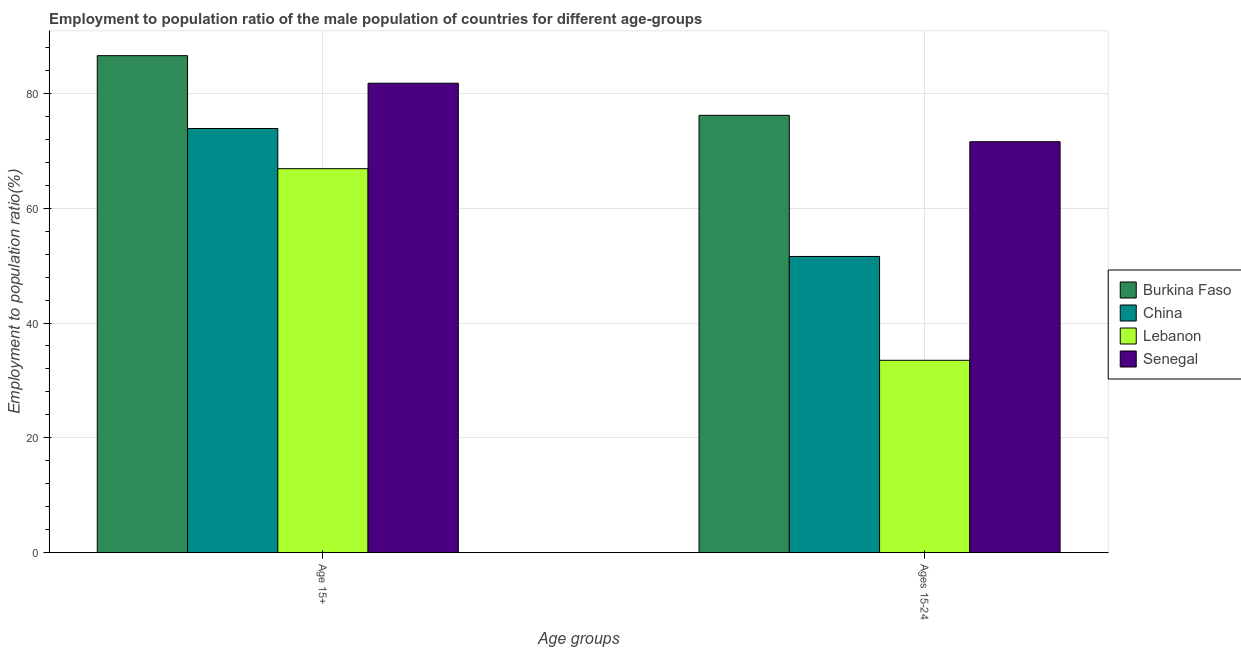How many different coloured bars are there?
Make the answer very short. 4. How many bars are there on the 2nd tick from the right?
Offer a terse response. 4. What is the label of the 1st group of bars from the left?
Your answer should be very brief. Age 15+. What is the employment to population ratio(age 15+) in Senegal?
Provide a short and direct response. 81.8. Across all countries, what is the maximum employment to population ratio(age 15-24)?
Keep it short and to the point. 76.2. Across all countries, what is the minimum employment to population ratio(age 15-24)?
Your answer should be very brief. 33.5. In which country was the employment to population ratio(age 15-24) maximum?
Give a very brief answer. Burkina Faso. In which country was the employment to population ratio(age 15+) minimum?
Provide a short and direct response. Lebanon. What is the total employment to population ratio(age 15-24) in the graph?
Your response must be concise. 232.9. What is the difference between the employment to population ratio(age 15+) in Burkina Faso and that in Senegal?
Offer a very short reply. 4.8. What is the difference between the employment to population ratio(age 15-24) in China and the employment to population ratio(age 15+) in Senegal?
Give a very brief answer. -30.2. What is the average employment to population ratio(age 15-24) per country?
Your response must be concise. 58.22. What is the difference between the employment to population ratio(age 15-24) and employment to population ratio(age 15+) in China?
Your response must be concise. -22.3. What is the ratio of the employment to population ratio(age 15+) in Lebanon to that in China?
Keep it short and to the point. 0.91. What does the 2nd bar from the left in Ages 15-24 represents?
Give a very brief answer. China. What does the 2nd bar from the right in Ages 15-24 represents?
Give a very brief answer. Lebanon. How many bars are there?
Offer a terse response. 8. What is the difference between two consecutive major ticks on the Y-axis?
Give a very brief answer. 20. Are the values on the major ticks of Y-axis written in scientific E-notation?
Your answer should be very brief. No. Does the graph contain grids?
Provide a succinct answer. Yes. Where does the legend appear in the graph?
Your answer should be very brief. Center right. How are the legend labels stacked?
Your answer should be compact. Vertical. What is the title of the graph?
Offer a terse response. Employment to population ratio of the male population of countries for different age-groups. Does "Costa Rica" appear as one of the legend labels in the graph?
Your answer should be very brief. No. What is the label or title of the X-axis?
Give a very brief answer. Age groups. What is the Employment to population ratio(%) in Burkina Faso in Age 15+?
Give a very brief answer. 86.6. What is the Employment to population ratio(%) in China in Age 15+?
Make the answer very short. 73.9. What is the Employment to population ratio(%) in Lebanon in Age 15+?
Make the answer very short. 66.9. What is the Employment to population ratio(%) of Senegal in Age 15+?
Keep it short and to the point. 81.8. What is the Employment to population ratio(%) in Burkina Faso in Ages 15-24?
Ensure brevity in your answer.  76.2. What is the Employment to population ratio(%) of China in Ages 15-24?
Keep it short and to the point. 51.6. What is the Employment to population ratio(%) in Lebanon in Ages 15-24?
Provide a succinct answer. 33.5. What is the Employment to population ratio(%) in Senegal in Ages 15-24?
Offer a terse response. 71.6. Across all Age groups, what is the maximum Employment to population ratio(%) in Burkina Faso?
Your response must be concise. 86.6. Across all Age groups, what is the maximum Employment to population ratio(%) in China?
Make the answer very short. 73.9. Across all Age groups, what is the maximum Employment to population ratio(%) in Lebanon?
Offer a very short reply. 66.9. Across all Age groups, what is the maximum Employment to population ratio(%) of Senegal?
Provide a succinct answer. 81.8. Across all Age groups, what is the minimum Employment to population ratio(%) in Burkina Faso?
Your response must be concise. 76.2. Across all Age groups, what is the minimum Employment to population ratio(%) of China?
Your response must be concise. 51.6. Across all Age groups, what is the minimum Employment to population ratio(%) in Lebanon?
Provide a short and direct response. 33.5. Across all Age groups, what is the minimum Employment to population ratio(%) of Senegal?
Keep it short and to the point. 71.6. What is the total Employment to population ratio(%) of Burkina Faso in the graph?
Give a very brief answer. 162.8. What is the total Employment to population ratio(%) in China in the graph?
Make the answer very short. 125.5. What is the total Employment to population ratio(%) of Lebanon in the graph?
Offer a terse response. 100.4. What is the total Employment to population ratio(%) in Senegal in the graph?
Offer a very short reply. 153.4. What is the difference between the Employment to population ratio(%) in Burkina Faso in Age 15+ and that in Ages 15-24?
Your response must be concise. 10.4. What is the difference between the Employment to population ratio(%) in China in Age 15+ and that in Ages 15-24?
Ensure brevity in your answer.  22.3. What is the difference between the Employment to population ratio(%) of Lebanon in Age 15+ and that in Ages 15-24?
Your response must be concise. 33.4. What is the difference between the Employment to population ratio(%) of Burkina Faso in Age 15+ and the Employment to population ratio(%) of China in Ages 15-24?
Provide a succinct answer. 35. What is the difference between the Employment to population ratio(%) in Burkina Faso in Age 15+ and the Employment to population ratio(%) in Lebanon in Ages 15-24?
Offer a very short reply. 53.1. What is the difference between the Employment to population ratio(%) in China in Age 15+ and the Employment to population ratio(%) in Lebanon in Ages 15-24?
Make the answer very short. 40.4. What is the difference between the Employment to population ratio(%) of Lebanon in Age 15+ and the Employment to population ratio(%) of Senegal in Ages 15-24?
Provide a succinct answer. -4.7. What is the average Employment to population ratio(%) in Burkina Faso per Age groups?
Your answer should be compact. 81.4. What is the average Employment to population ratio(%) of China per Age groups?
Give a very brief answer. 62.75. What is the average Employment to population ratio(%) in Lebanon per Age groups?
Provide a succinct answer. 50.2. What is the average Employment to population ratio(%) in Senegal per Age groups?
Keep it short and to the point. 76.7. What is the difference between the Employment to population ratio(%) of Burkina Faso and Employment to population ratio(%) of China in Age 15+?
Offer a terse response. 12.7. What is the difference between the Employment to population ratio(%) of Lebanon and Employment to population ratio(%) of Senegal in Age 15+?
Offer a terse response. -14.9. What is the difference between the Employment to population ratio(%) of Burkina Faso and Employment to population ratio(%) of China in Ages 15-24?
Your response must be concise. 24.6. What is the difference between the Employment to population ratio(%) of Burkina Faso and Employment to population ratio(%) of Lebanon in Ages 15-24?
Provide a succinct answer. 42.7. What is the difference between the Employment to population ratio(%) in China and Employment to population ratio(%) in Lebanon in Ages 15-24?
Give a very brief answer. 18.1. What is the difference between the Employment to population ratio(%) in Lebanon and Employment to population ratio(%) in Senegal in Ages 15-24?
Your answer should be compact. -38.1. What is the ratio of the Employment to population ratio(%) in Burkina Faso in Age 15+ to that in Ages 15-24?
Ensure brevity in your answer.  1.14. What is the ratio of the Employment to population ratio(%) of China in Age 15+ to that in Ages 15-24?
Your response must be concise. 1.43. What is the ratio of the Employment to population ratio(%) of Lebanon in Age 15+ to that in Ages 15-24?
Provide a succinct answer. 2. What is the ratio of the Employment to population ratio(%) in Senegal in Age 15+ to that in Ages 15-24?
Keep it short and to the point. 1.14. What is the difference between the highest and the second highest Employment to population ratio(%) of Burkina Faso?
Your answer should be compact. 10.4. What is the difference between the highest and the second highest Employment to population ratio(%) of China?
Provide a short and direct response. 22.3. What is the difference between the highest and the second highest Employment to population ratio(%) of Lebanon?
Provide a short and direct response. 33.4. What is the difference between the highest and the lowest Employment to population ratio(%) of Burkina Faso?
Keep it short and to the point. 10.4. What is the difference between the highest and the lowest Employment to population ratio(%) in China?
Your answer should be very brief. 22.3. What is the difference between the highest and the lowest Employment to population ratio(%) in Lebanon?
Your answer should be compact. 33.4. 